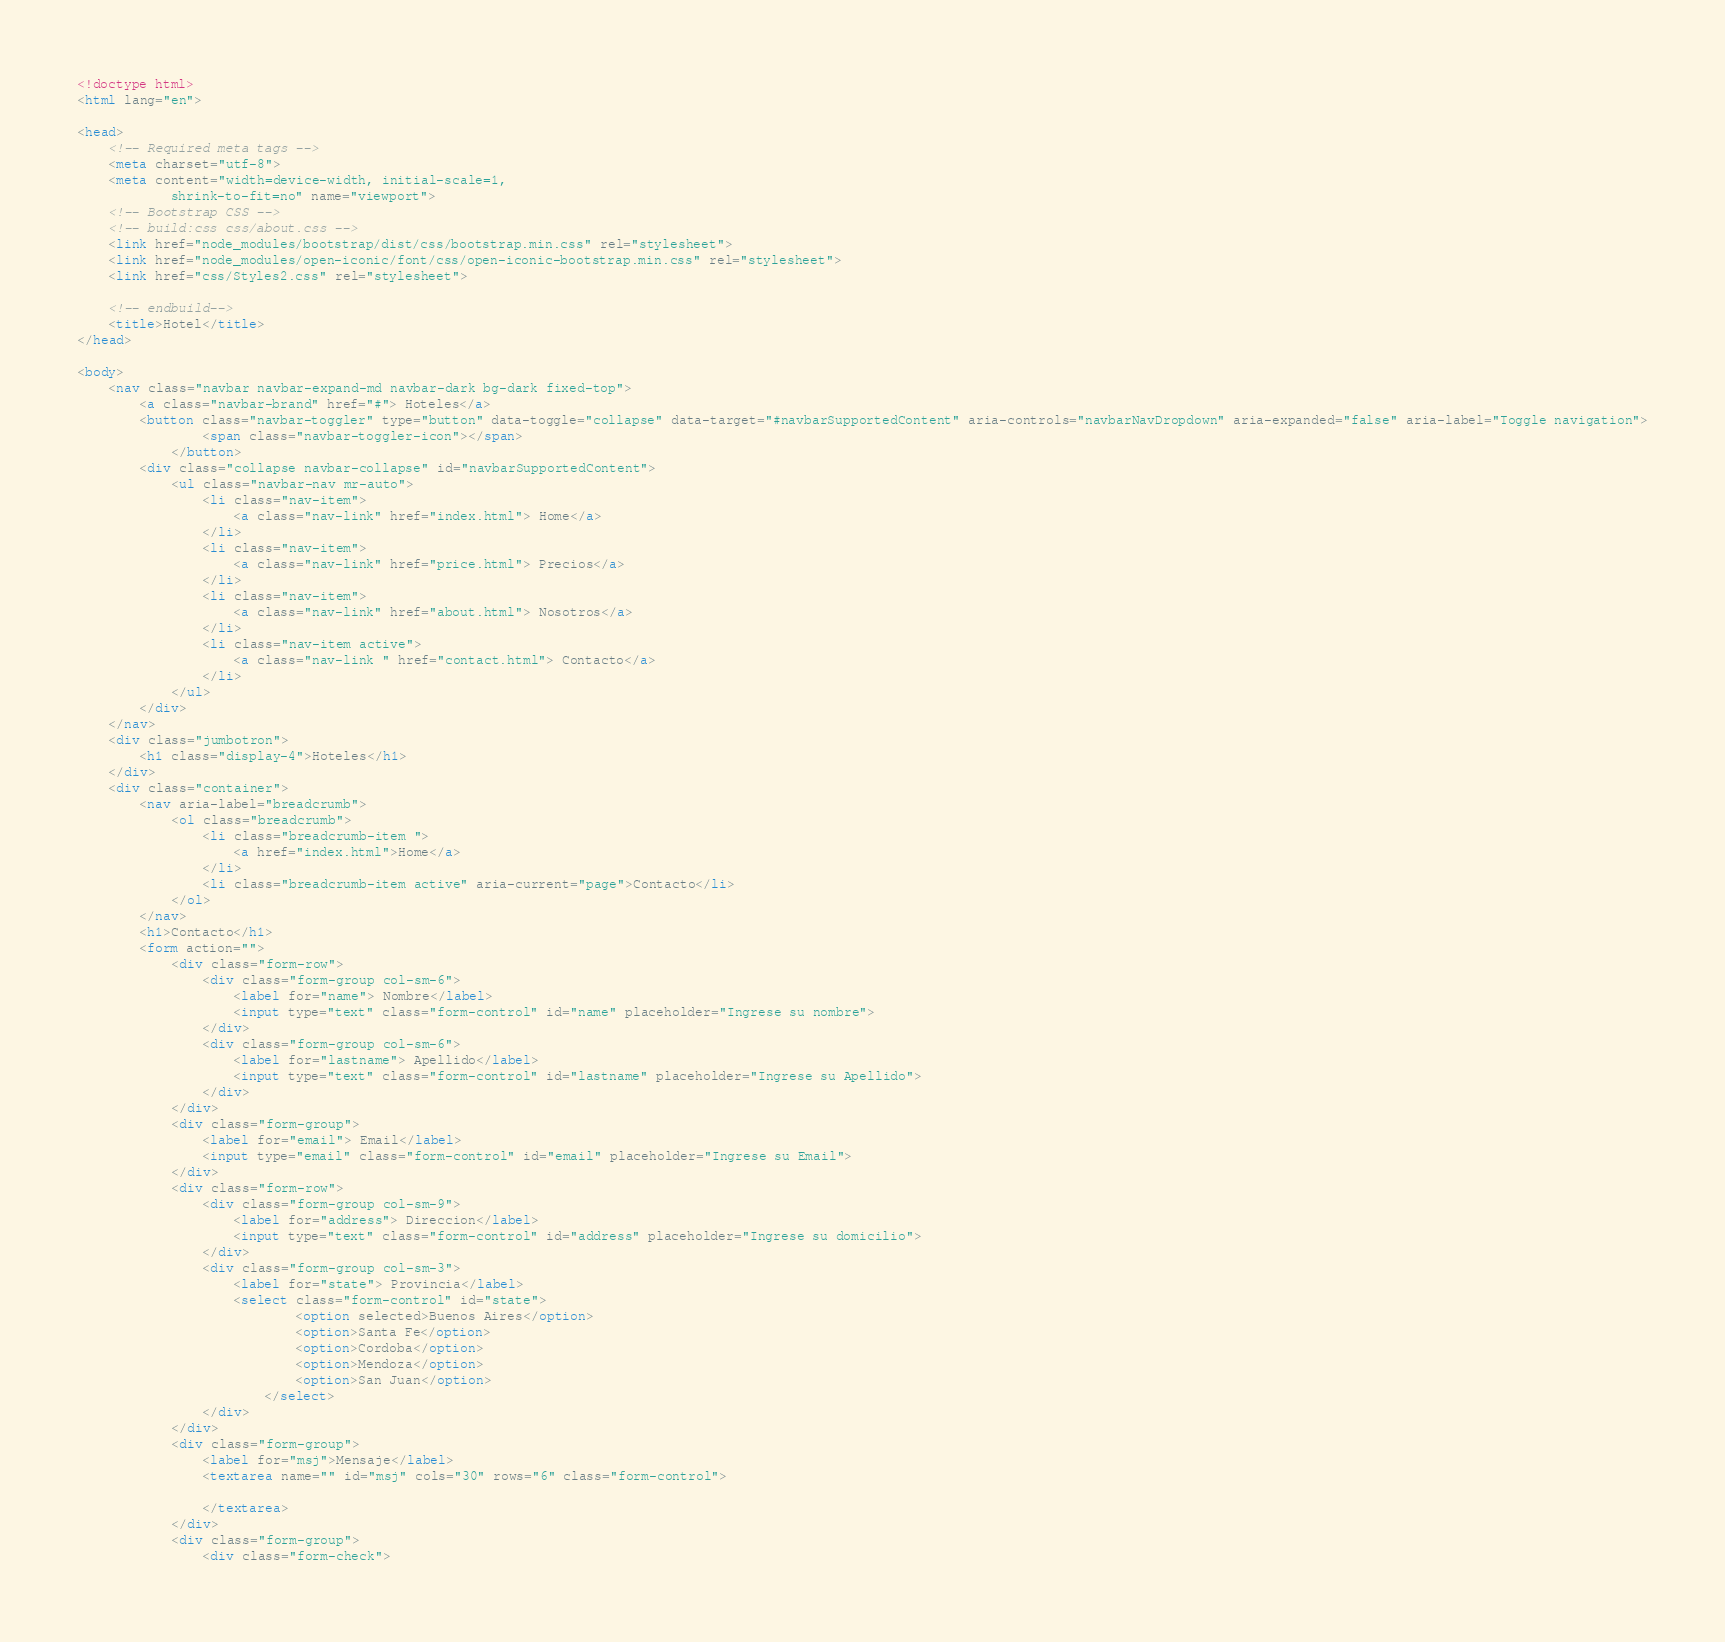<code> <loc_0><loc_0><loc_500><loc_500><_HTML_><!doctype html>
<html lang="en">

<head>
    <!-- Required meta tags -->
    <meta charset="utf-8">
    <meta content="width=device-width, initial-scale=1,
            shrink-to-fit=no" name="viewport">
    <!-- Bootstrap CSS -->
    <!-- build:css css/about.css -->
    <link href="node_modules/bootstrap/dist/css/bootstrap.min.css" rel="stylesheet">
    <link href="node_modules/open-iconic/font/css/open-iconic-bootstrap.min.css" rel="stylesheet">
    <link href="css/Styles2.css" rel="stylesheet">

    <!-- endbuild-->
    <title>Hotel</title>
</head>

<body>
    <nav class="navbar navbar-expand-md navbar-dark bg-dark fixed-top">
        <a class="navbar-brand" href="#"> Hoteles</a>
        <button class="navbar-toggler" type="button" data-toggle="collapse" data-target="#navbarSupportedContent" aria-controls="navbarNavDropdown" aria-expanded="false" aria-label="Toggle navigation">
                <span class="navbar-toggler-icon"></span>
            </button>
        <div class="collapse navbar-collapse" id="navbarSupportedContent">
            <ul class="navbar-nav mr-auto">
                <li class="nav-item">
                    <a class="nav-link" href="index.html"> Home</a>
                </li>
                <li class="nav-item">
                    <a class="nav-link" href="price.html"> Precios</a>
                </li>
                <li class="nav-item">
                    <a class="nav-link" href="about.html"> Nosotros</a>
                </li>
                <li class="nav-item active">
                    <a class="nav-link " href="contact.html"> Contacto</a>
                </li>
            </ul>
        </div>
    </nav>
    <div class="jumbotron">
        <h1 class="display-4">Hoteles</h1>
    </div>
    <div class="container">
        <nav aria-label="breadcrumb">
            <ol class="breadcrumb">
                <li class="breadcrumb-item ">
                    <a href="index.html">Home</a>
                </li>
                <li class="breadcrumb-item active" aria-current="page">Contacto</li>
            </ol>
        </nav>
        <h1>Contacto</h1>
        <form action="">
            <div class="form-row">
                <div class="form-group col-sm-6">
                    <label for="name"> Nombre</label>
                    <input type="text" class="form-control" id="name" placeholder="Ingrese su nombre">
                </div>
                <div class="form-group col-sm-6">
                    <label for="lastname"> Apellido</label>
                    <input type="text" class="form-control" id="lastname" placeholder="Ingrese su Apellido">
                </div>
            </div>
            <div class="form-group">
                <label for="email"> Email</label>
                <input type="email" class="form-control" id="email" placeholder="Ingrese su Email">
            </div>
            <div class="form-row">
                <div class="form-group col-sm-9">
                    <label for="address"> Direccion</label>
                    <input type="text" class="form-control" id="address" placeholder="Ingrese su domicilio">
                </div>
                <div class="form-group col-sm-3">
                    <label for="state"> Provincia</label>
                    <select class="form-control" id="state">
                            <option selected>Buenos Aires</option>
                            <option>Santa Fe</option>
                            <option>Cordoba</option>
                            <option>Mendoza</option>
                            <option>San Juan</option>
                        </select>
                </div>
            </div>
            <div class="form-group">
                <label for="msj">Mensaje</label>
                <textarea name="" id="msj" cols="30" rows="6" class="form-control">
                    
                </textarea>
            </div>
            <div class="form-group">
                <div class="form-check"></code> 